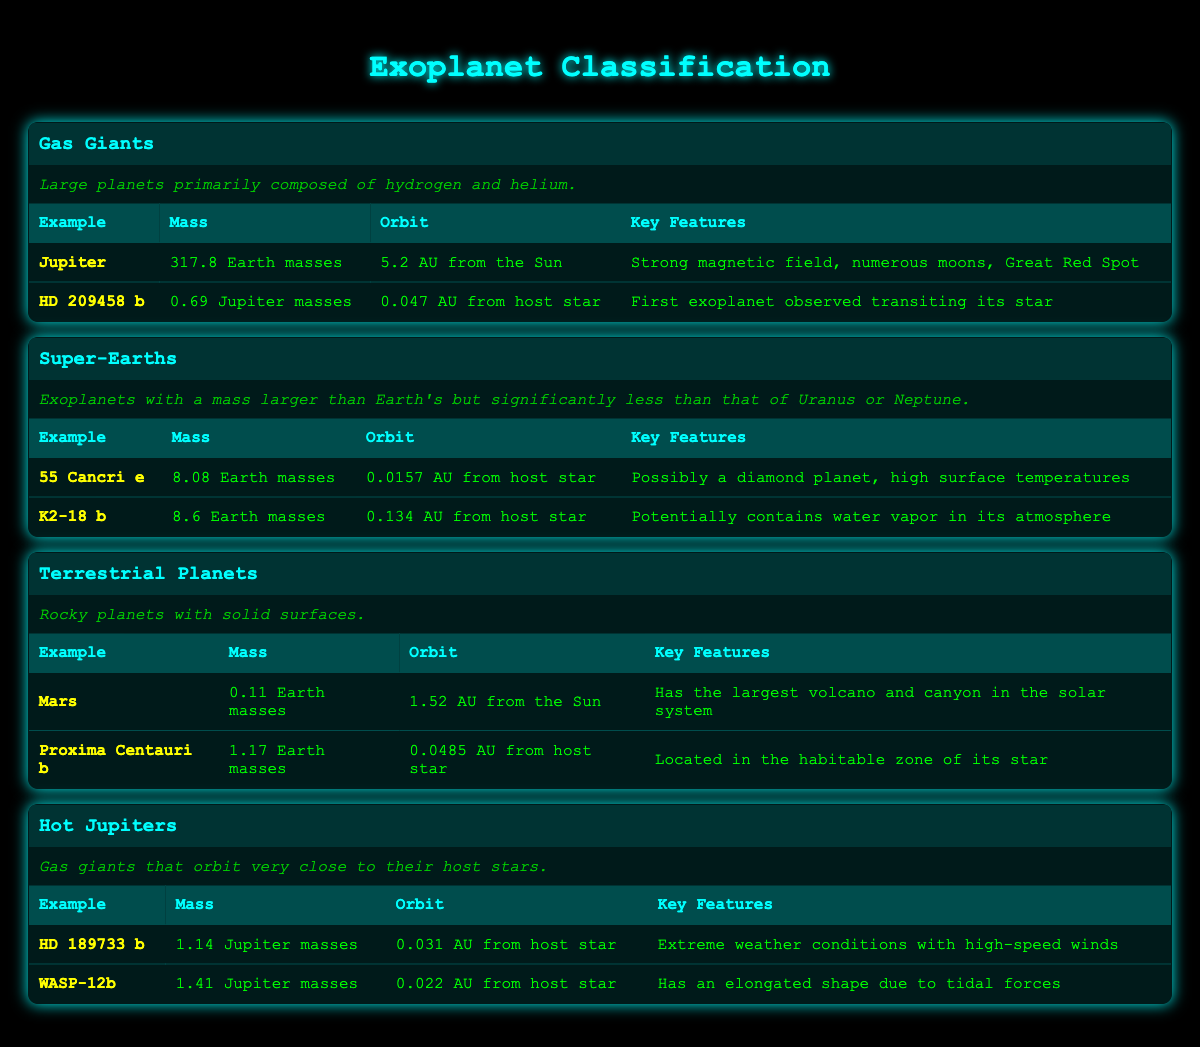What is the mass of the planet Jupiter? In the table under the "Gas Giants" type, the mass of Jupiter is listed as "317.8 Earth masses."
Answer: 317.8 Earth masses Which exoplanet is located in the habitable zone of its star? The table indicates that "Proxima Centauri b" is located in the habitable zone of its star, as noted in its key features.
Answer: Proxima Centauri b What are the mass ranges for Super-Earths? Super-Earths are defined in the table as having a mass larger than Earth's but significantly less than that of Uranus or Neptune, typically between 1 and 20 Earth masses. However, specific mass values are provided for the examples, which are 8.08 and 8.6 Earth masses.
Answer: 8.08 to 8.6 Earth masses Is "WASP-12b" a gas giant? According to the classification in the table, "WASP-12b" is categorized under "Hot Jupiters," which are a type of gas giant, confirming that it is indeed a gas giant.
Answer: Yes What is the average mass of the Super-Earths listed? The Super-Earths listed have masses of 8.08 and 8.6 Earth masses. To find the average, we add the two masses: 8.08 + 8.6 = 16.68, then divide by 2, giving us an average mass of 8.34 Earth masses.
Answer: 8.34 Earth masses Which exoplanet has the strongest magnetic field? The table indicates that "Jupiter" is noted for having a strong magnetic field among its key features listed under gas giants.
Answer: Jupiter Which exoplanet has an elongated shape due to tidal forces? In the table under "Hot Jupiters," "WASP-12b" is specifically mentioned to have an elongated shape due to tidal forces as one of its key features.
Answer: WASP-12b What is the orbital distance of "HD 209458 b" from its host star? The table states that "HD 209458 b" orbits at "0.047 AU from its host star."
Answer: 0.047 AU What is the combined mass of "Mars" and "Proxima Centauri b"? The mass of Mars is "0.11 Earth masses" and that of Proxima Centauri b is "1.17 Earth masses." Adding these two together gives us 0.11 + 1.17 = 1.28 Earth masses as the combined mass.
Answer: 1.28 Earth masses 